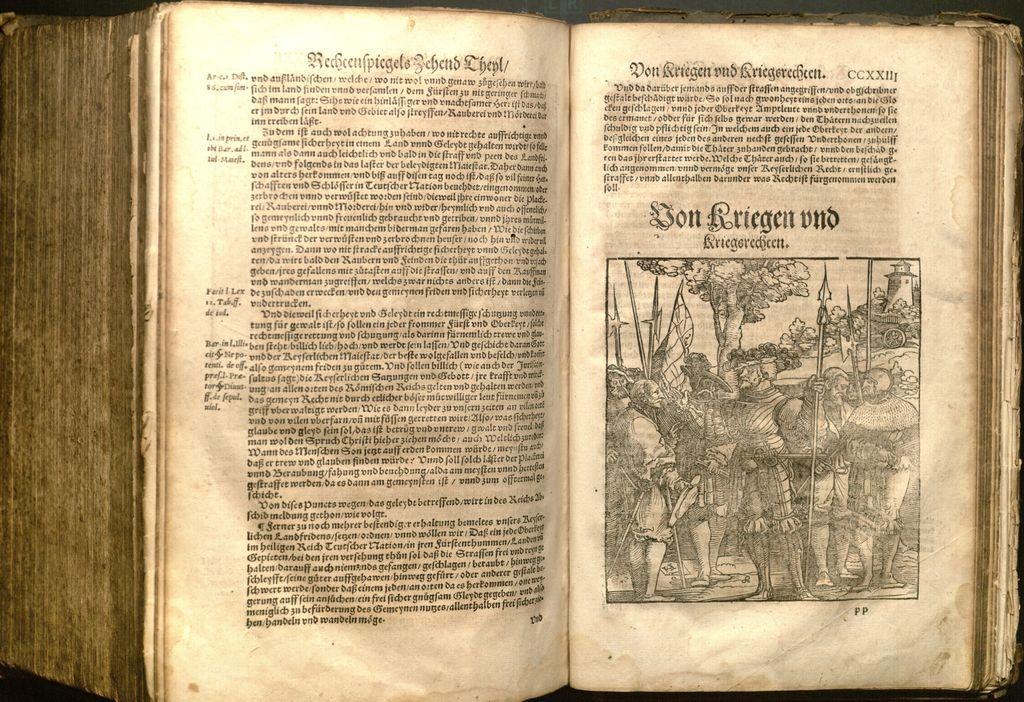What object can be seen in the picture? There is a book in the picture. What is special about the book? The book has a picture. Who else is in the picture besides the book? There are people standing in the picture. What are the people holding? The people are holding weapons. What can be seen in the background of the picture? There are plants and trees in the backdrop. How many apples are being carried by the flock of dogs in the image? There are no apples or dogs present in the image. What type of dog can be seen interacting with the people in the image? There are no dogs present in the image; only people and a book are visible. 